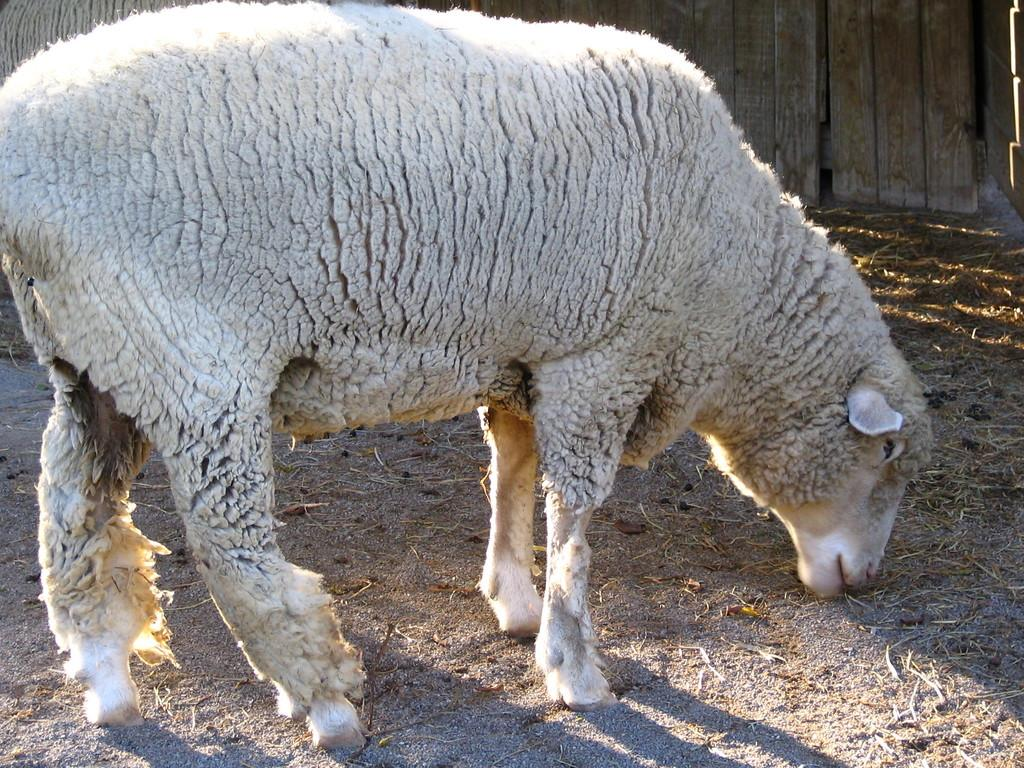What type of animals are present in the image? There are sheep in the image. What is the sheep standing on? The sheep are standing on a surface. What can be seen in the background of the image? There is a wooden fence in the image. How does the pollution affect the sheep in the image? There is no mention of pollution in the image, so we cannot determine its effect on the sheep. 